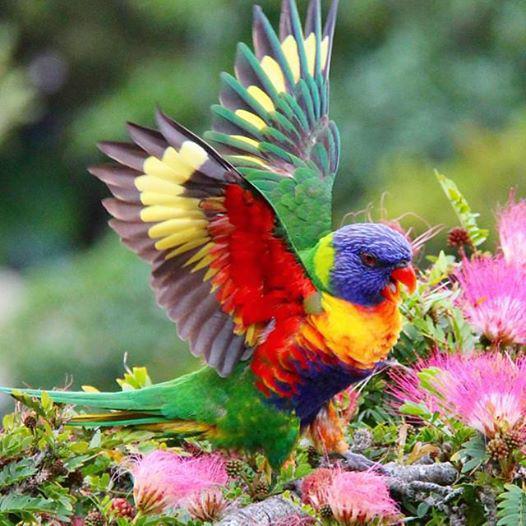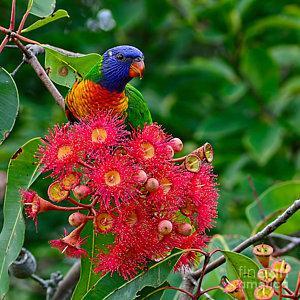The first image is the image on the left, the second image is the image on the right. Evaluate the accuracy of this statement regarding the images: "A blue-headed bird with non-spread wings is perched among dark pink flowers with tendril petals.". Is it true? Answer yes or no. Yes. The first image is the image on the left, the second image is the image on the right. Considering the images on both sides, is "At least one brightly colored bird perches on a branch with pink flowers." valid? Answer yes or no. Yes. 